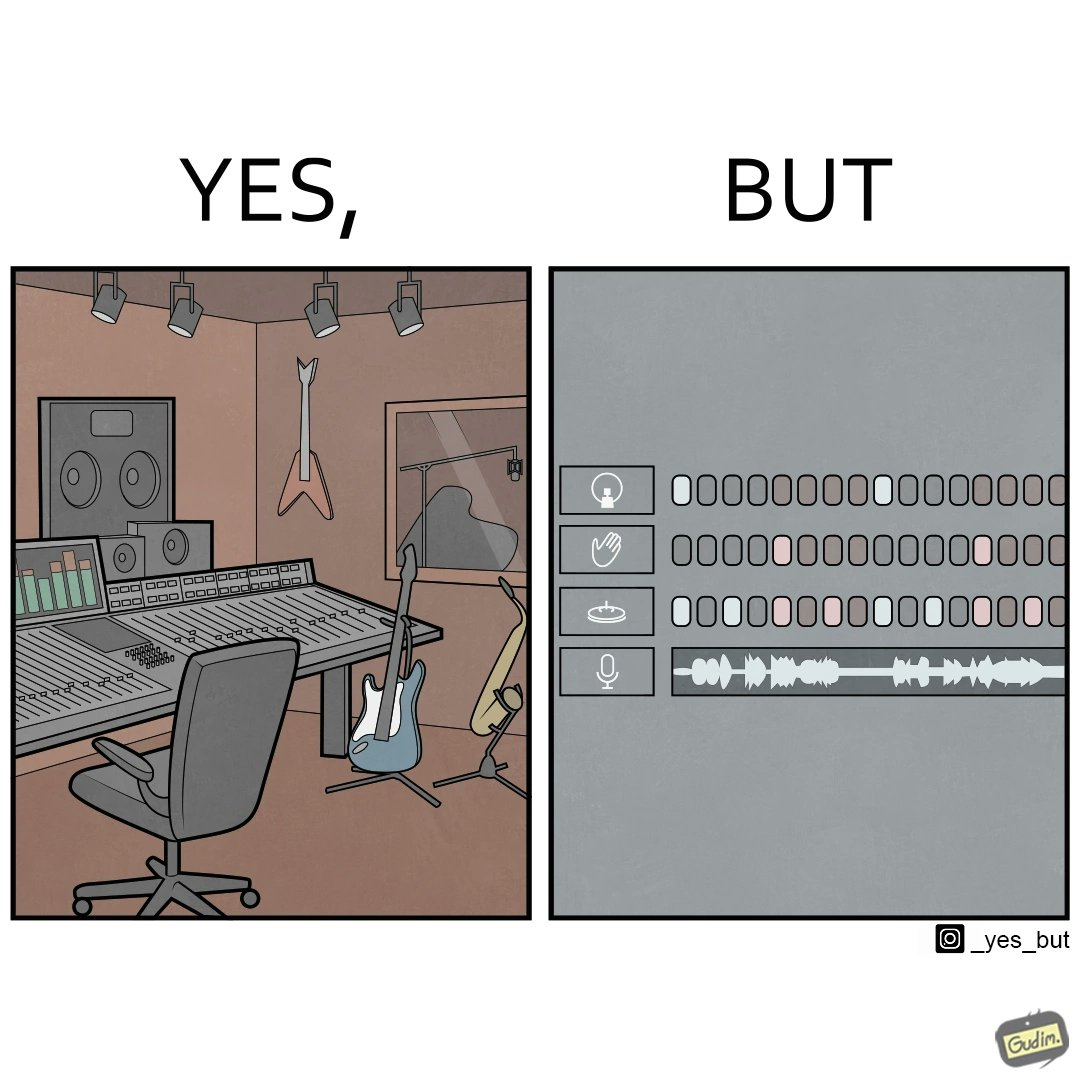What is shown in the left half versus the right half of this image? In the left part of the image: The image shows a music studio with differnt kinds of instruments like guitar and saxophone, piano and recording  to make music. In the right part of the image: The image shows the view of an electornic equipment used to create music. It has buttons to record, play drums and other musical instruments. 